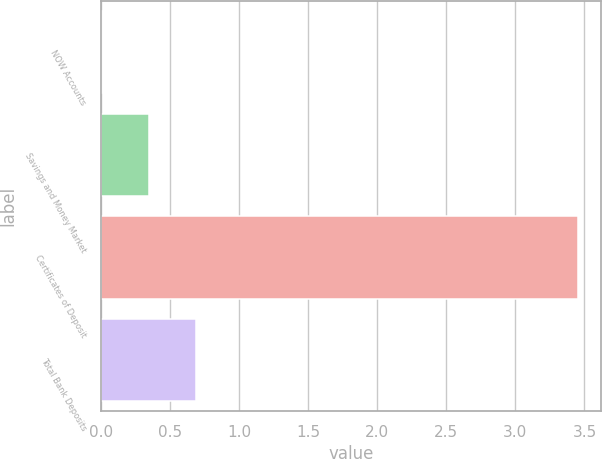<chart> <loc_0><loc_0><loc_500><loc_500><bar_chart><fcel>NOW Accounts<fcel>Savings and Money Market<fcel>Certificates of Deposit<fcel>Total Bank Deposits<nl><fcel>0.01<fcel>0.35<fcel>3.45<fcel>0.69<nl></chart> 